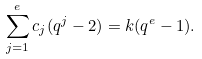<formula> <loc_0><loc_0><loc_500><loc_500>\sum _ { j = 1 } ^ { e } c _ { j } ( q ^ { j } - 2 ) = k ( q ^ { e } - 1 ) .</formula> 